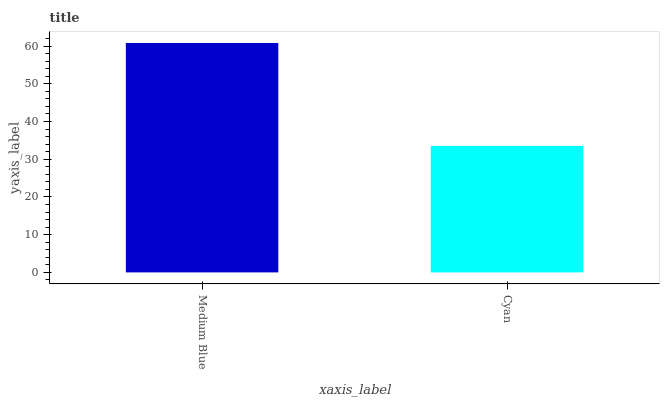Is Cyan the minimum?
Answer yes or no. Yes. Is Medium Blue the maximum?
Answer yes or no. Yes. Is Cyan the maximum?
Answer yes or no. No. Is Medium Blue greater than Cyan?
Answer yes or no. Yes. Is Cyan less than Medium Blue?
Answer yes or no. Yes. Is Cyan greater than Medium Blue?
Answer yes or no. No. Is Medium Blue less than Cyan?
Answer yes or no. No. Is Medium Blue the high median?
Answer yes or no. Yes. Is Cyan the low median?
Answer yes or no. Yes. Is Cyan the high median?
Answer yes or no. No. Is Medium Blue the low median?
Answer yes or no. No. 